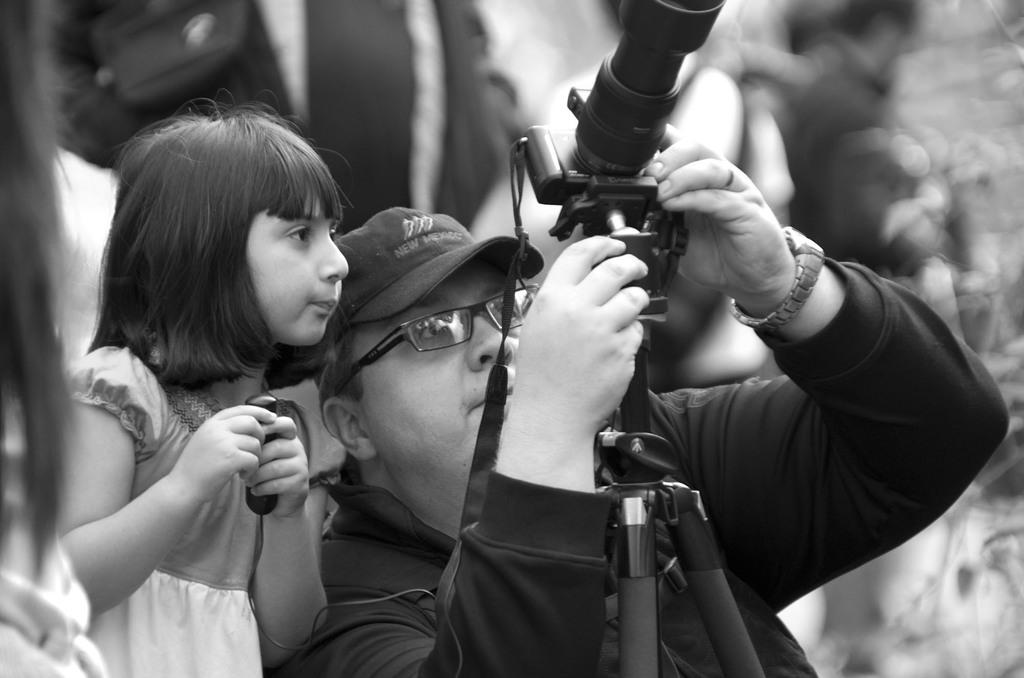What is the person in the image wearing? The person in the image is wearing a black dress. What is the person holding in the image? The person is holding a camera. How is the camera positioned in the image? The camera is on a stand. Who else is present in the image? There is a kid standing beside the person with the camera. What type of nose can be seen on the kid in the image? There is no mention of a nose in the provided facts, and no nose is visible in the image. 